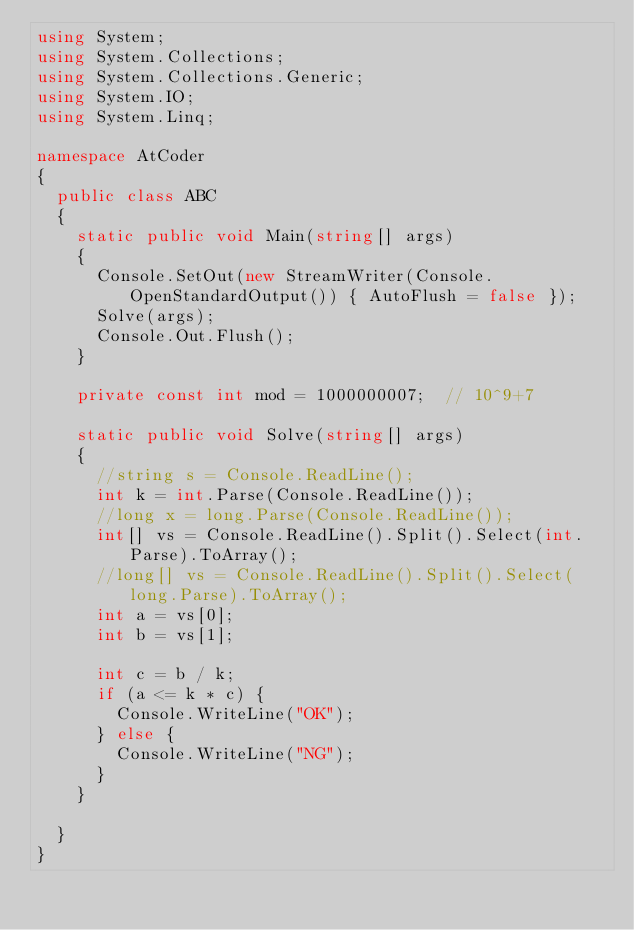<code> <loc_0><loc_0><loc_500><loc_500><_C#_>using System;
using System.Collections;
using System.Collections.Generic;
using System.IO;
using System.Linq;

namespace AtCoder
{
	public class ABC
	{
		static public void Main(string[] args)
		{
			Console.SetOut(new StreamWriter(Console.OpenStandardOutput()) { AutoFlush = false });
			Solve(args);
			Console.Out.Flush();
		}

		private const int mod = 1000000007;  // 10^9+7

		static public void Solve(string[] args)
		{
			//string s = Console.ReadLine();
			int k = int.Parse(Console.ReadLine());
			//long x = long.Parse(Console.ReadLine());
			int[] vs = Console.ReadLine().Split().Select(int.Parse).ToArray();
			//long[] vs = Console.ReadLine().Split().Select(long.Parse).ToArray();
			int a = vs[0];
			int b = vs[1];

			int c = b / k;
			if (a <= k * c) {
				Console.WriteLine("OK");
			} else {
				Console.WriteLine("NG");
			}
		}

	}
}
</code> 